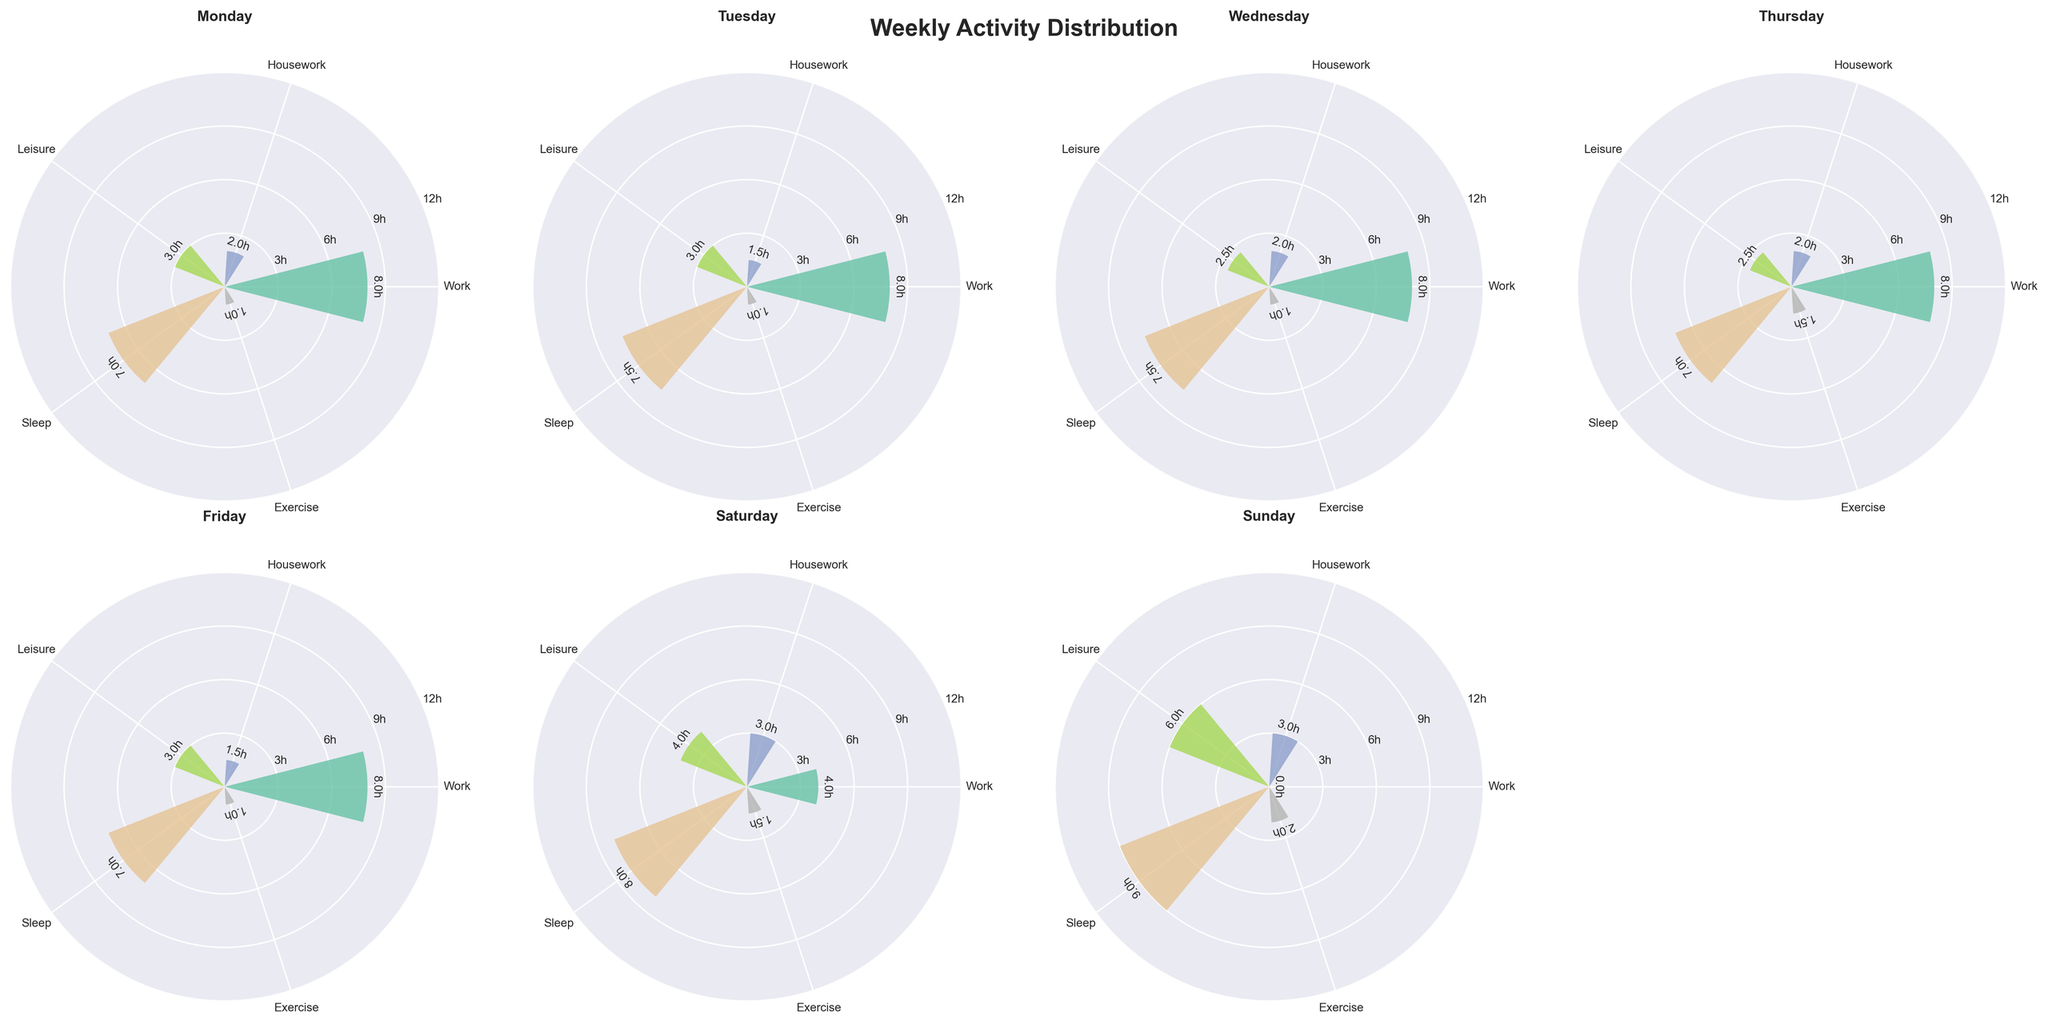What's the main activity on Monday? The main activity on each day is the one with the highest hours. On Monday, the tallest bar is for Work at 8 hours.
Answer: Work How many hours are spent on Sleep on Sunday? The Sleep bar on Sunday is 9 hours tall.
Answer: 9 hours Which day has the least hours of Exercise? By comparing the Exercise bars across all days, Monday, Tuesday, Wednesday, and Friday each show 1 hour.
Answer: Monday, Tuesday, Wednesday, Friday Compare the total hours of Leisure on weekdays to weekends. Leisure hours on weekdays (Mon-Fri) are: 3, 3, 2.5, 2.5, 3 = 14 hours. On weekends (Sat-Sun): 4, 6 = 10 hours.
Answer: Weekdays: 14 hours, Weekends: 10 hours On which day is the most time spent on Housework? The tallest Housework bar is on Saturday at 3 hours.
Answer: Saturday What is the average number of hours spent on Exercise during the week? The daily Exercise hours are: 1, 1, 1, 1.5, 1, 1.5, 2. Total = 9 hours, divided by 7 days = 1.29 hours (approx).
Answer: 1.29 hours Is there any day where no hours were spent on Work? On Sunday's subplot, the Work bar is at 0 hours.
Answer: Sunday How does the distribution of activities vary between Monday and Sunday? Monday's most time-consuming activity is Work (8 hours) with minimal Leisure and Exercise. On Sunday, the most time is spent on Sleep (9 hours) and Leisure (6 hours), with no Work.
Answer: Monday: Work-heavy, Sunday: Leisure and Sleep-heavy 